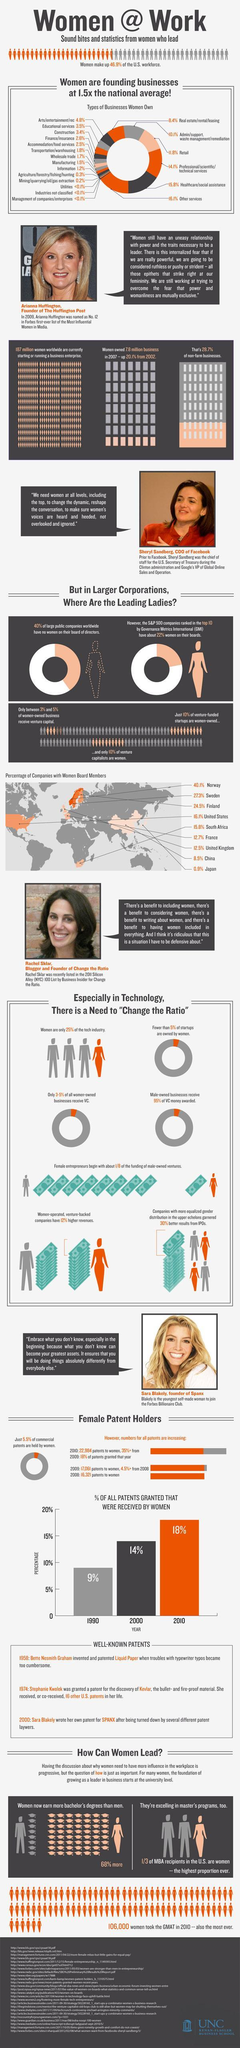What is the percentage of companies with women board members in China and Japan, taken together?
Answer the question with a short phrase. 9.4% What is the percentage of patents received by women in the year 2000 and 2010, taken together? 32% What is the percentage of companies with women board members in the US and UK, taken together? 28.6% What is the percentage of companies with women board members in Norway and Sweden, taken together? 67.4% What is the percentage of companies with women board members in Finland and France, taken together? 37.2% 